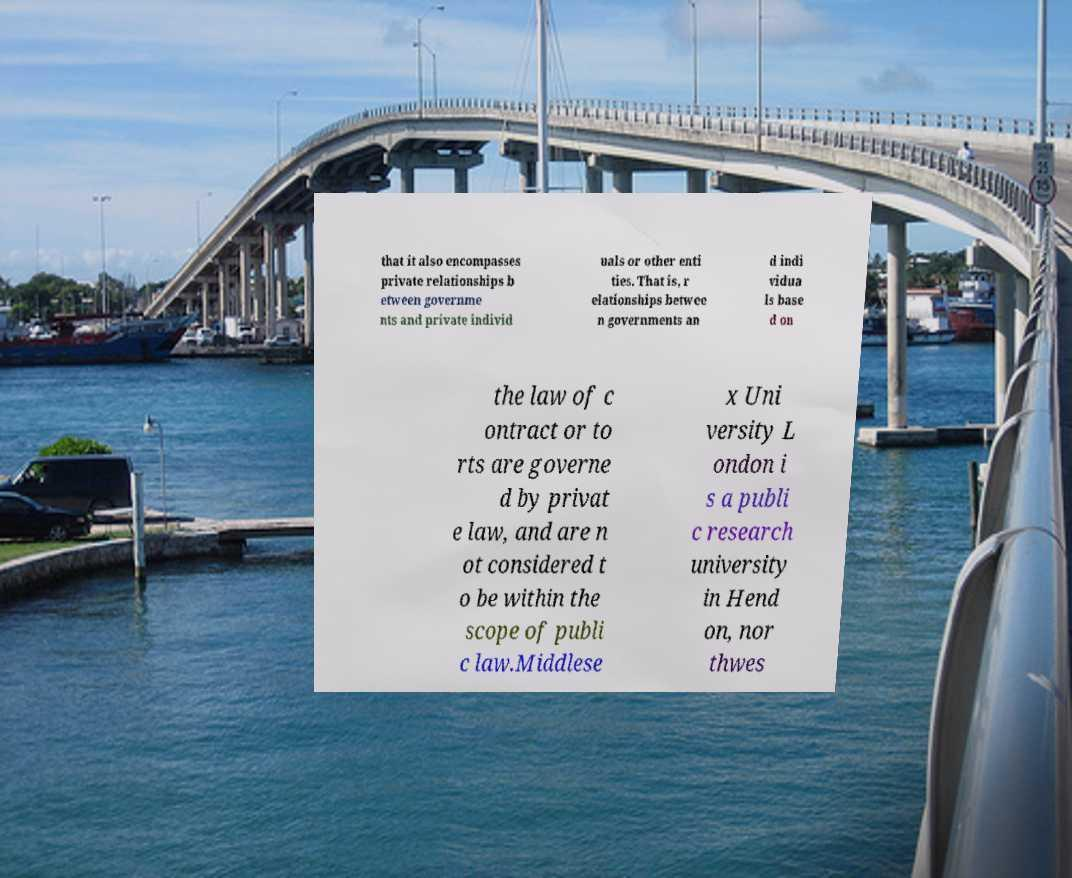I need the written content from this picture converted into text. Can you do that? that it also encompasses private relationships b etween governme nts and private individ uals or other enti ties. That is, r elationships betwee n governments an d indi vidua ls base d on the law of c ontract or to rts are governe d by privat e law, and are n ot considered t o be within the scope of publi c law.Middlese x Uni versity L ondon i s a publi c research university in Hend on, nor thwes 